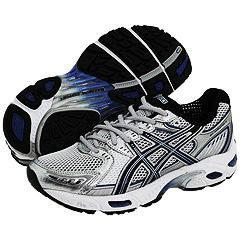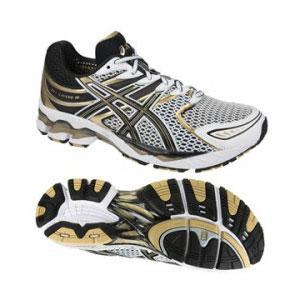The first image is the image on the left, the second image is the image on the right. Given the left and right images, does the statement "At least one image shows a pair of shoes that lacks the color red." hold true? Answer yes or no. Yes. The first image is the image on the left, the second image is the image on the right. Assess this claim about the two images: "There is no more than one tennis shoe in the left image.". Correct or not? Answer yes or no. No. 